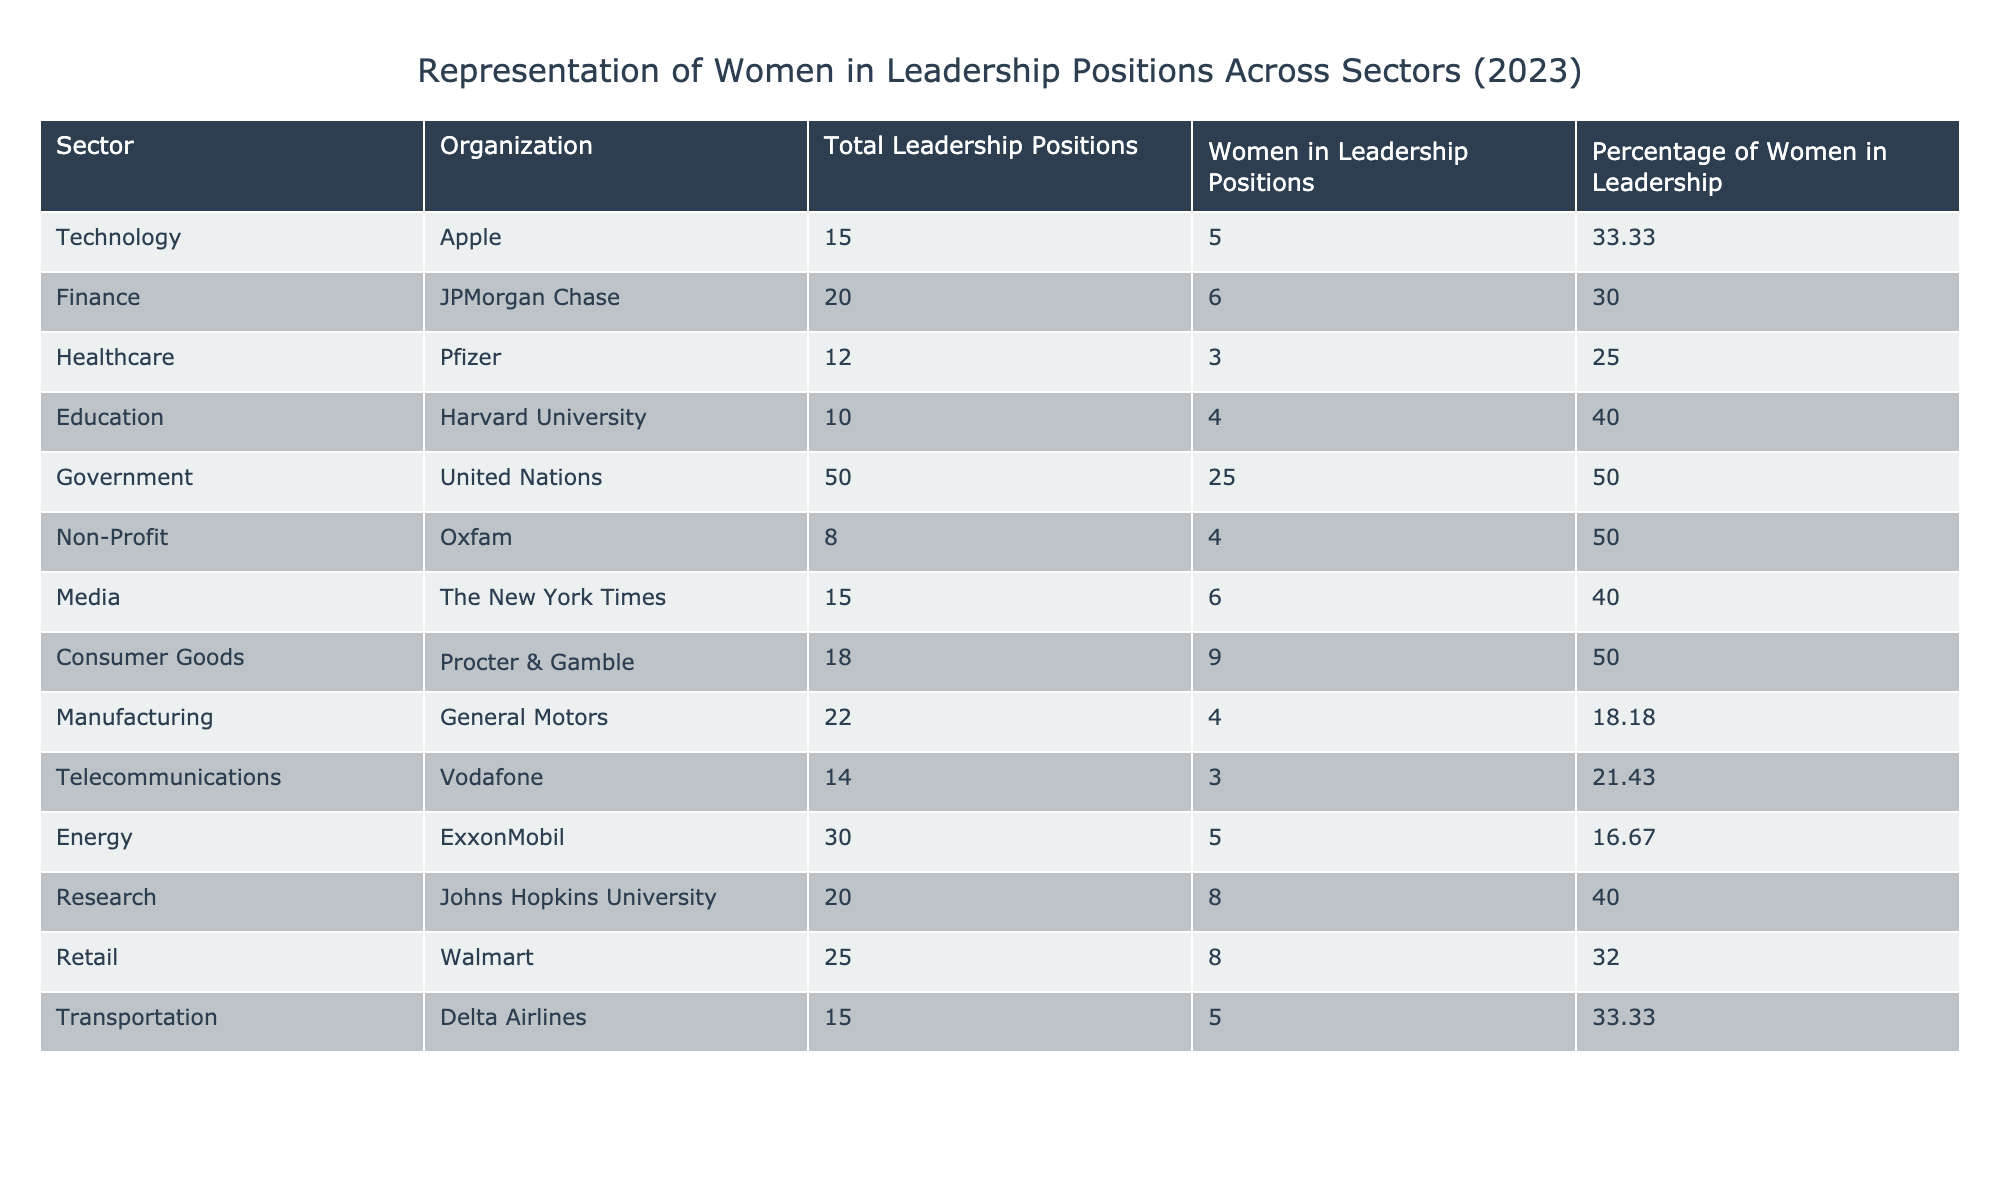What is the percentage of women in leadership positions at Apple? The table shows the percentage of women in leadership positions at Apple as 33.33%.
Answer: 33.33% Which sector has the highest representation of women in leadership positions? The Government sector has the highest percentage at 50%, as indicated in the table.
Answer: Government How many total leadership positions are there in the Healthcare sector? The total leadership positions in the Healthcare sector, as per the table, is 12.
Answer: 12 What is the average percentage of women in leadership across all sectors listed? To find the average, sum the percentages (33.33 + 30 + 25 + 40 + 50 + 50 + 40 + 50 + 18.18 + 21.43 + 16.67 + 40 + 32 + 33.33 =  15 values = 404.87) and divide by 14, resulting in approximately 28.91%.
Answer: 28.91% Is the percentage of women in leadership at Procter & Gamble higher than that at Pfizer? At Procter & Gamble, the percentage is 50%, while at Pfizer, it is only 25%. Therefore, it is true that Procter & Gamble has a higher percentage.
Answer: Yes How many more women leaders does the United Nations have compared to Walmart? The United Nations has 25 women in leadership positions, while Walmart has 8. The difference is 25 - 8 = 17.
Answer: 17 What percentage of leadership positions in the Energy sector is held by women? The table indicates that in the Energy sector, 16.67% of leadership positions are held by women.
Answer: 16.67% Which organization has the fewest women in leadership positions among those listed in the table? General Motors has the fewest women in leadership positions, with only 4, as shown in the table.
Answer: General Motors What is the total number of leadership positions across all sectors? To find the total, sum all the total leadership positions: (15 + 20 + 12 + 10 + 50 + 8 + 15 + 18 + 22 + 14 + 30 + 20 + 25 + 15 =  20 values = 335).
Answer: 335 Are the percentages of women in leadership positions at the Non-Profit sector equal to the Education sector? The Non-Profit sector has 50%, while Education has 40%. Therefore, they are not equal.
Answer: No 